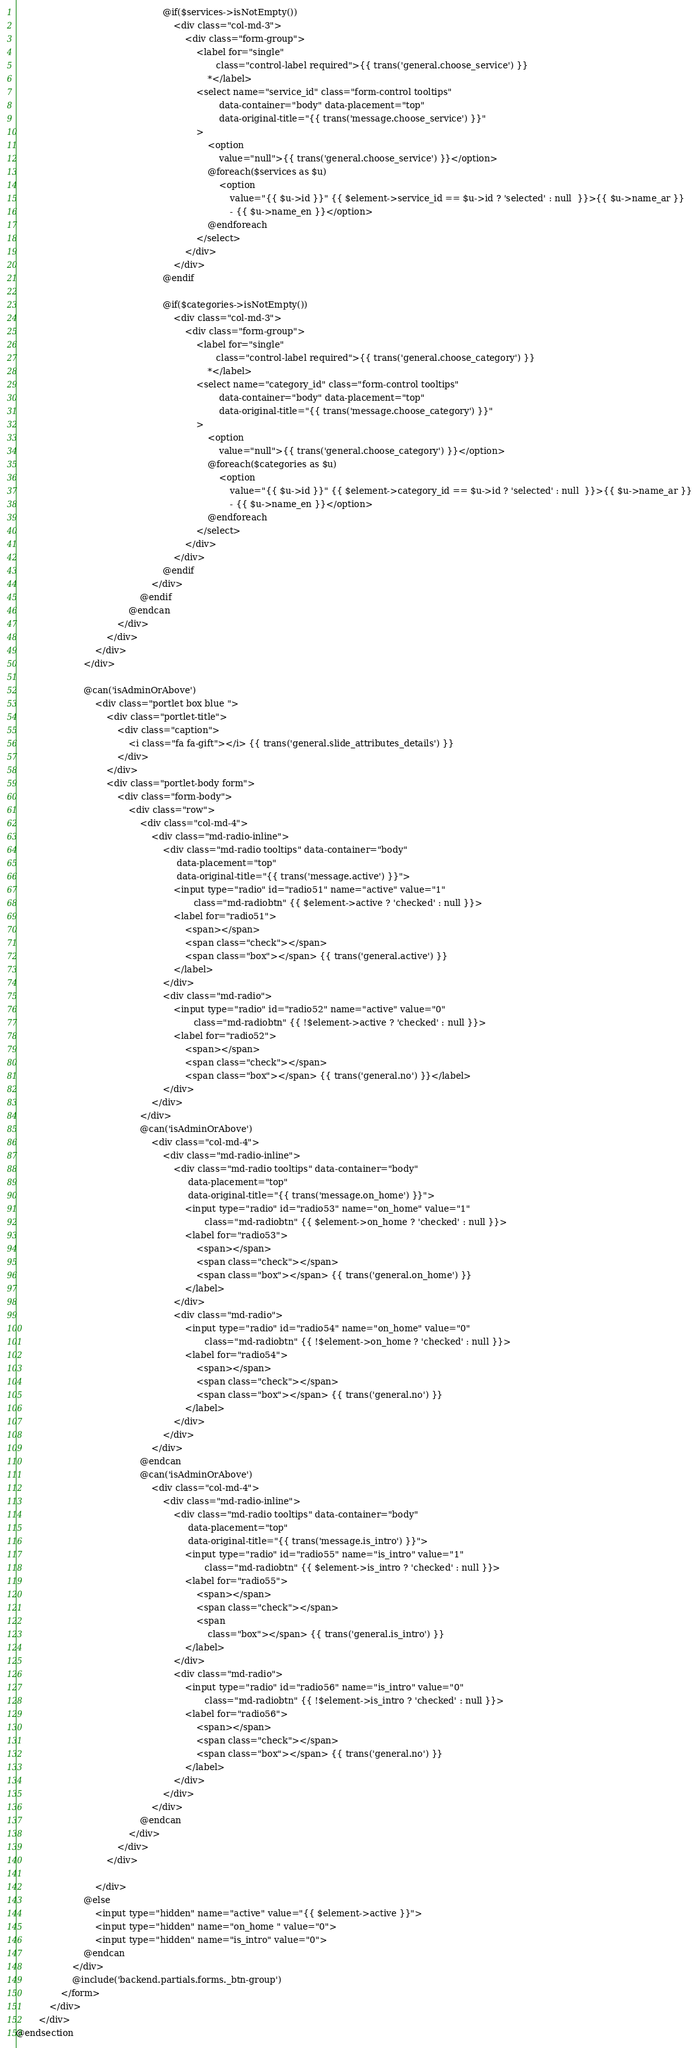Convert code to text. <code><loc_0><loc_0><loc_500><loc_500><_PHP_>                                                    @if($services->isNotEmpty())
                                                        <div class="col-md-3">
                                                            <div class="form-group">
                                                                <label for="single"
                                                                       class="control-label required">{{ trans('general.choose_service') }}
                                                                    *</label>
                                                                <select name="service_id" class="form-control tooltips"
                                                                        data-container="body" data-placement="top"
                                                                        data-original-title="{{ trans('message.choose_service') }}"
                                                                >
                                                                    <option
                                                                        value="null">{{ trans('general.choose_service') }}</option>
                                                                    @foreach($services as $u)
                                                                        <option
                                                                            value="{{ $u->id }}" {{ $element->service_id == $u->id ? 'selected' : null  }}>{{ $u->name_ar }}
                                                                            - {{ $u->name_en }}</option>
                                                                    @endforeach
                                                                </select>
                                                            </div>
                                                        </div>
                                                    @endif

                                                    @if($categories->isNotEmpty())
                                                        <div class="col-md-3">
                                                            <div class="form-group">
                                                                <label for="single"
                                                                       class="control-label required">{{ trans('general.choose_category') }}
                                                                    *</label>
                                                                <select name="category_id" class="form-control tooltips"
                                                                        data-container="body" data-placement="top"
                                                                        data-original-title="{{ trans('message.choose_category') }}"
                                                                >
                                                                    <option
                                                                        value="null">{{ trans('general.choose_category') }}</option>
                                                                    @foreach($categories as $u)
                                                                        <option
                                                                            value="{{ $u->id }}" {{ $element->category_id == $u->id ? 'selected' : null  }}>{{ $u->name_ar }}
                                                                            - {{ $u->name_en }}</option>
                                                                    @endforeach
                                                                </select>
                                                            </div>
                                                        </div>
                                                    @endif
                                                </div>
                                            @endif
                                        @endcan
                                    </div>
                                </div>
                            </div>
                        </div>

                        @can('isAdminOrAbove')
                            <div class="portlet box blue ">
                                <div class="portlet-title">
                                    <div class="caption">
                                        <i class="fa fa-gift"></i> {{ trans('general.slide_attributes_details') }}
                                    </div>
                                </div>
                                <div class="portlet-body form">
                                    <div class="form-body">
                                        <div class="row">
                                            <div class="col-md-4">
                                                <div class="md-radio-inline">
                                                    <div class="md-radio tooltips" data-container="body"
                                                         data-placement="top"
                                                         data-original-title="{{ trans('message.active') }}">
                                                        <input type="radio" id="radio51" name="active" value="1"
                                                               class="md-radiobtn" {{ $element->active ? 'checked' : null }}>
                                                        <label for="radio51">
                                                            <span></span>
                                                            <span class="check"></span>
                                                            <span class="box"></span> {{ trans('general.active') }}
                                                        </label>
                                                    </div>
                                                    <div class="md-radio">
                                                        <input type="radio" id="radio52" name="active" value="0"
                                                               class="md-radiobtn" {{ !$element->active ? 'checked' : null }}>
                                                        <label for="radio52">
                                                            <span></span>
                                                            <span class="check"></span>
                                                            <span class="box"></span> {{ trans('general.no') }}</label>
                                                    </div>
                                                </div>
                                            </div>
                                            @can('isAdminOrAbove')
                                                <div class="col-md-4">
                                                    <div class="md-radio-inline">
                                                        <div class="md-radio tooltips" data-container="body"
                                                             data-placement="top"
                                                             data-original-title="{{ trans('message.on_home') }}">
                                                            <input type="radio" id="radio53" name="on_home" value="1"
                                                                   class="md-radiobtn" {{ $element->on_home ? 'checked' : null }}>
                                                            <label for="radio53">
                                                                <span></span>
                                                                <span class="check"></span>
                                                                <span class="box"></span> {{ trans('general.on_home') }}
                                                            </label>
                                                        </div>
                                                        <div class="md-radio">
                                                            <input type="radio" id="radio54" name="on_home" value="0"
                                                                   class="md-radiobtn" {{ !$element->on_home ? 'checked' : null }}>
                                                            <label for="radio54">
                                                                <span></span>
                                                                <span class="check"></span>
                                                                <span class="box"></span> {{ trans('general.no') }}
                                                            </label>
                                                        </div>
                                                    </div>
                                                </div>
                                            @endcan
                                            @can('isAdminOrAbove')
                                                <div class="col-md-4">
                                                    <div class="md-radio-inline">
                                                        <div class="md-radio tooltips" data-container="body"
                                                             data-placement="top"
                                                             data-original-title="{{ trans('message.is_intro') }}">
                                                            <input type="radio" id="radio55" name="is_intro" value="1"
                                                                   class="md-radiobtn" {{ $element->is_intro ? 'checked' : null }}>
                                                            <label for="radio55">
                                                                <span></span>
                                                                <span class="check"></span>
                                                                <span
                                                                    class="box"></span> {{ trans('general.is_intro') }}
                                                            </label>
                                                        </div>
                                                        <div class="md-radio">
                                                            <input type="radio" id="radio56" name="is_intro" value="0"
                                                                   class="md-radiobtn" {{ !$element->is_intro ? 'checked' : null }}>
                                                            <label for="radio56">
                                                                <span></span>
                                                                <span class="check"></span>
                                                                <span class="box"></span> {{ trans('general.no') }}
                                                            </label>
                                                        </div>
                                                    </div>
                                                </div>
                                            @endcan
                                        </div>
                                    </div>
                                </div>

                            </div>
                        @else
                            <input type="hidden" name="active" value="{{ $element->active }}">
                            <input type="hidden" name="on_home " value="0">
                            <input type="hidden" name="is_intro" value="0">
                        @endcan
                    </div>
                    @include('backend.partials.forms._btn-group')
                </form>
            </div>
        </div>
@endsection
</code> 